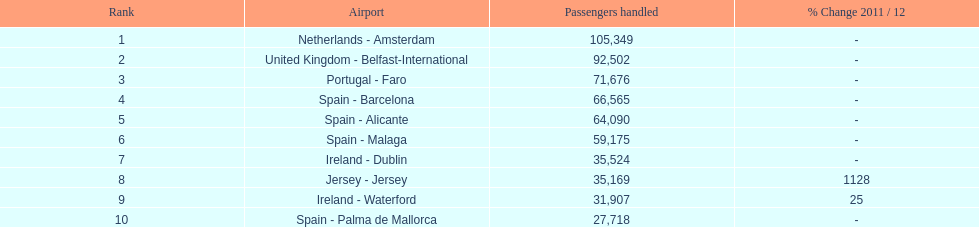What is the name of the only airport in portugal that is among the 10 busiest routes to and from london southend airport in 2012? Portugal - Faro. 